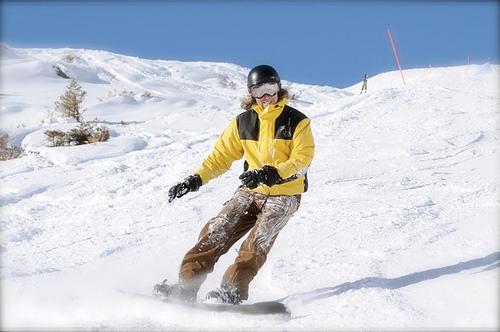What sport is depicted?
Short answer required. Snowboarding. What is on the man's head?
Concise answer only. Helmet. Is the man wearing goggles?
Keep it brief. Yes. 